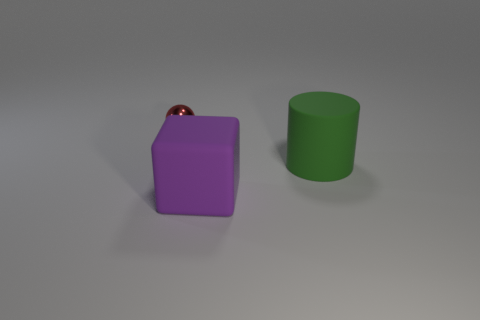Add 1 rubber objects. How many objects exist? 4 Subtract all balls. How many objects are left? 2 Subtract all cylinders. Subtract all tiny red metal balls. How many objects are left? 1 Add 3 big purple rubber objects. How many big purple rubber objects are left? 4 Add 2 blocks. How many blocks exist? 3 Subtract 0 brown cylinders. How many objects are left? 3 